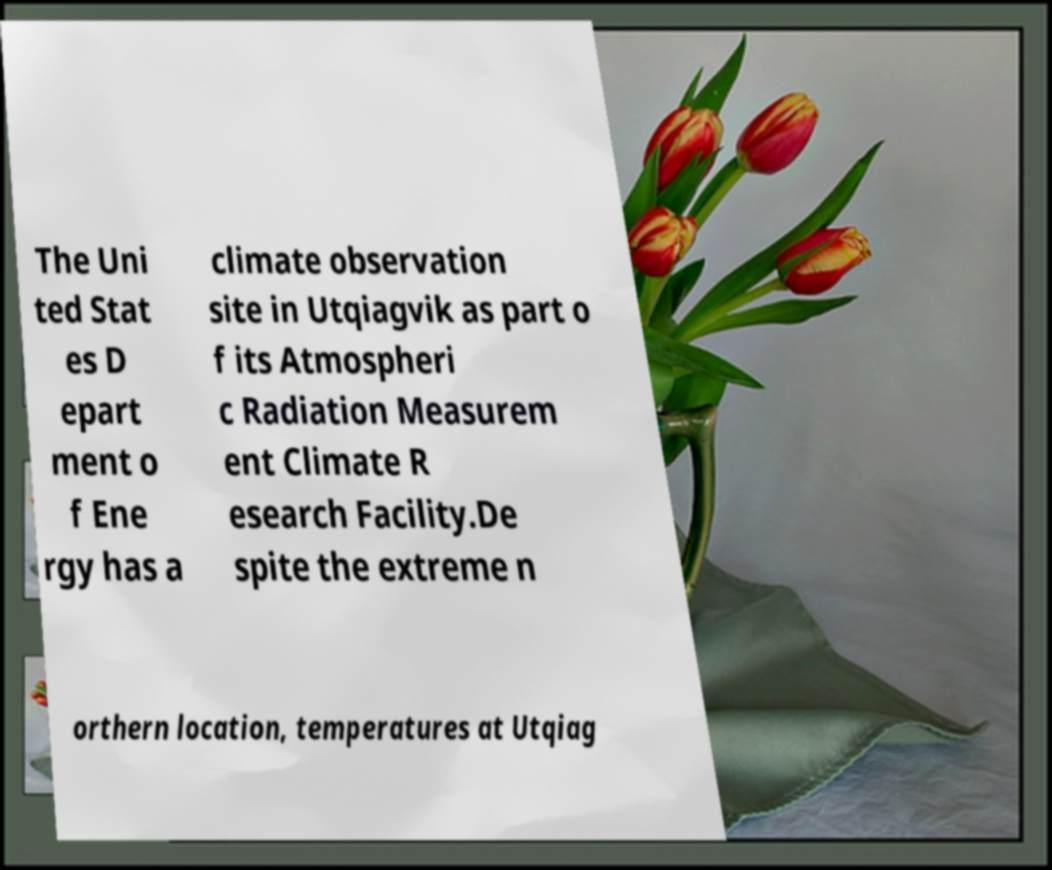Could you extract and type out the text from this image? The Uni ted Stat es D epart ment o f Ene rgy has a climate observation site in Utqiagvik as part o f its Atmospheri c Radiation Measurem ent Climate R esearch Facility.De spite the extreme n orthern location, temperatures at Utqiag 